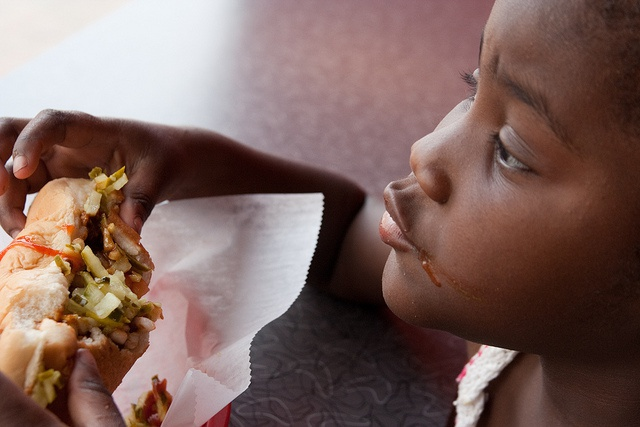Describe the objects in this image and their specific colors. I can see people in white, black, maroon, gray, and brown tones and sandwich in white, maroon, tan, and brown tones in this image. 